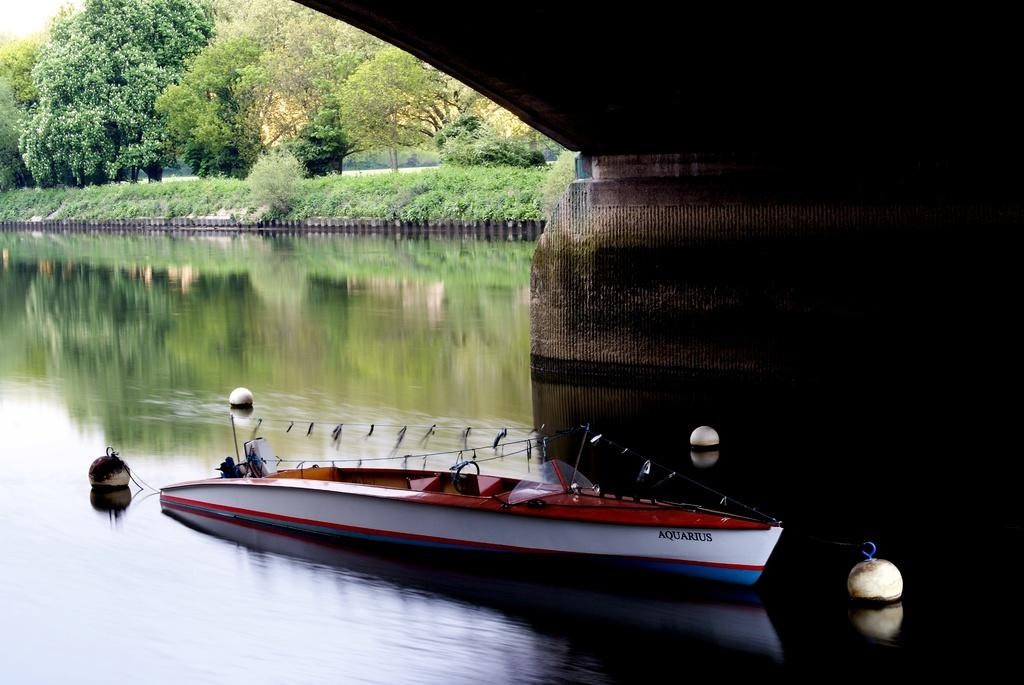What is the primary element present in the image? There is water in the image. What type of vehicle can be seen in the water? There is a boat in the image. What type of vegetation is visible in the image? There are trees and plants in the image. What else can be seen in the water besides the boat? There are objects in the water. What type of land can be seen in the image? There is no land visible in the image; it primarily features water. What type of structure is present in the image? There is no structure present in the image; it primarily features water, a boat, and vegetation. 